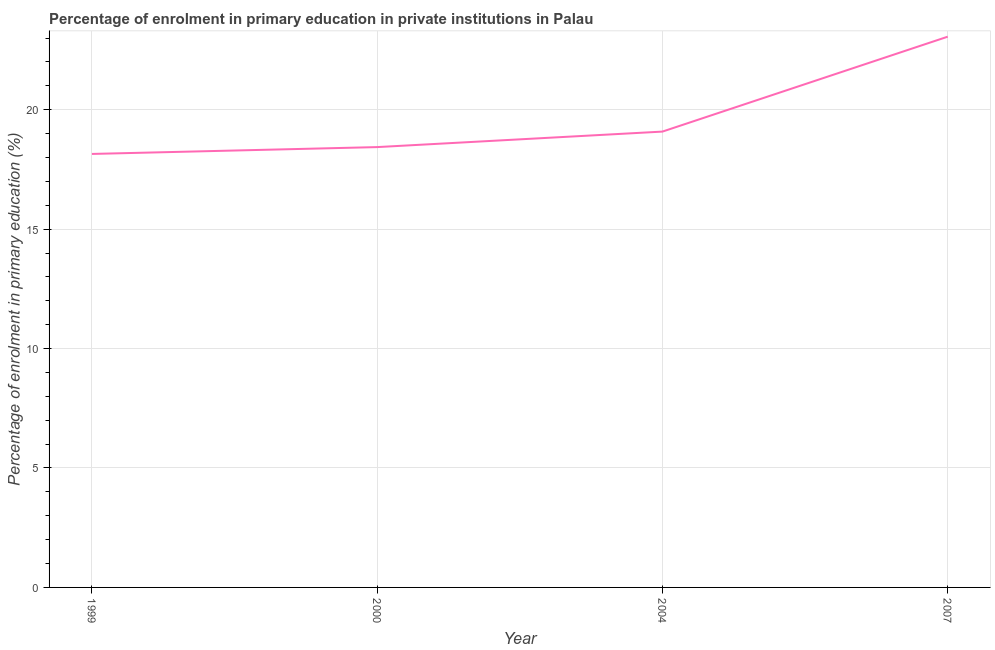What is the enrolment percentage in primary education in 2000?
Offer a terse response. 18.43. Across all years, what is the maximum enrolment percentage in primary education?
Give a very brief answer. 23.06. Across all years, what is the minimum enrolment percentage in primary education?
Your answer should be very brief. 18.15. In which year was the enrolment percentage in primary education minimum?
Give a very brief answer. 1999. What is the sum of the enrolment percentage in primary education?
Give a very brief answer. 78.72. What is the difference between the enrolment percentage in primary education in 1999 and 2000?
Your answer should be compact. -0.29. What is the average enrolment percentage in primary education per year?
Your answer should be compact. 19.68. What is the median enrolment percentage in primary education?
Your answer should be very brief. 18.76. Do a majority of the years between 2004 and 2000 (inclusive) have enrolment percentage in primary education greater than 13 %?
Ensure brevity in your answer.  No. What is the ratio of the enrolment percentage in primary education in 1999 to that in 2007?
Offer a terse response. 0.79. What is the difference between the highest and the second highest enrolment percentage in primary education?
Offer a very short reply. 3.97. Is the sum of the enrolment percentage in primary education in 1999 and 2004 greater than the maximum enrolment percentage in primary education across all years?
Your response must be concise. Yes. What is the difference between the highest and the lowest enrolment percentage in primary education?
Ensure brevity in your answer.  4.91. In how many years, is the enrolment percentage in primary education greater than the average enrolment percentage in primary education taken over all years?
Your answer should be very brief. 1. Does the enrolment percentage in primary education monotonically increase over the years?
Ensure brevity in your answer.  Yes. What is the difference between two consecutive major ticks on the Y-axis?
Make the answer very short. 5. Are the values on the major ticks of Y-axis written in scientific E-notation?
Offer a terse response. No. Does the graph contain grids?
Your response must be concise. Yes. What is the title of the graph?
Your answer should be compact. Percentage of enrolment in primary education in private institutions in Palau. What is the label or title of the X-axis?
Give a very brief answer. Year. What is the label or title of the Y-axis?
Your answer should be very brief. Percentage of enrolment in primary education (%). What is the Percentage of enrolment in primary education (%) in 1999?
Give a very brief answer. 18.15. What is the Percentage of enrolment in primary education (%) in 2000?
Make the answer very short. 18.43. What is the Percentage of enrolment in primary education (%) in 2004?
Give a very brief answer. 19.08. What is the Percentage of enrolment in primary education (%) in 2007?
Provide a succinct answer. 23.06. What is the difference between the Percentage of enrolment in primary education (%) in 1999 and 2000?
Your response must be concise. -0.29. What is the difference between the Percentage of enrolment in primary education (%) in 1999 and 2004?
Offer a terse response. -0.94. What is the difference between the Percentage of enrolment in primary education (%) in 1999 and 2007?
Give a very brief answer. -4.91. What is the difference between the Percentage of enrolment in primary education (%) in 2000 and 2004?
Give a very brief answer. -0.65. What is the difference between the Percentage of enrolment in primary education (%) in 2000 and 2007?
Your answer should be very brief. -4.62. What is the difference between the Percentage of enrolment in primary education (%) in 2004 and 2007?
Keep it short and to the point. -3.97. What is the ratio of the Percentage of enrolment in primary education (%) in 1999 to that in 2000?
Provide a succinct answer. 0.98. What is the ratio of the Percentage of enrolment in primary education (%) in 1999 to that in 2004?
Your response must be concise. 0.95. What is the ratio of the Percentage of enrolment in primary education (%) in 1999 to that in 2007?
Provide a short and direct response. 0.79. What is the ratio of the Percentage of enrolment in primary education (%) in 2000 to that in 2004?
Provide a short and direct response. 0.97. What is the ratio of the Percentage of enrolment in primary education (%) in 2000 to that in 2007?
Make the answer very short. 0.8. What is the ratio of the Percentage of enrolment in primary education (%) in 2004 to that in 2007?
Make the answer very short. 0.83. 